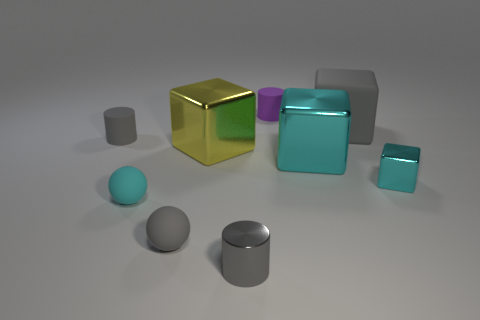Can you describe the colors and materials of the objects in this image? Certainly! The objects display a variety of colors and materials. There's a shiny gold cube and a metallic teal block that both have reflective surfaces. The matte cylinder on the right appears to be made of rubber with a deep purple color. Similarly, a small sphere and a larger cylinder share a matte, rubbery texture in a shade of gray. A small teal cube also seems matte and potentially rubberized. The diversity of textures and colors makes this an interesting arrangement to observe. 